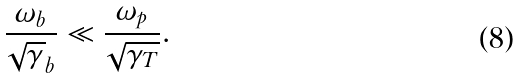Convert formula to latex. <formula><loc_0><loc_0><loc_500><loc_500>\frac { \omega _ { b } } { \sqrt { \gamma } _ { b } } \ll \frac { \omega _ { p } } { \sqrt { \gamma _ { T } } } .</formula> 